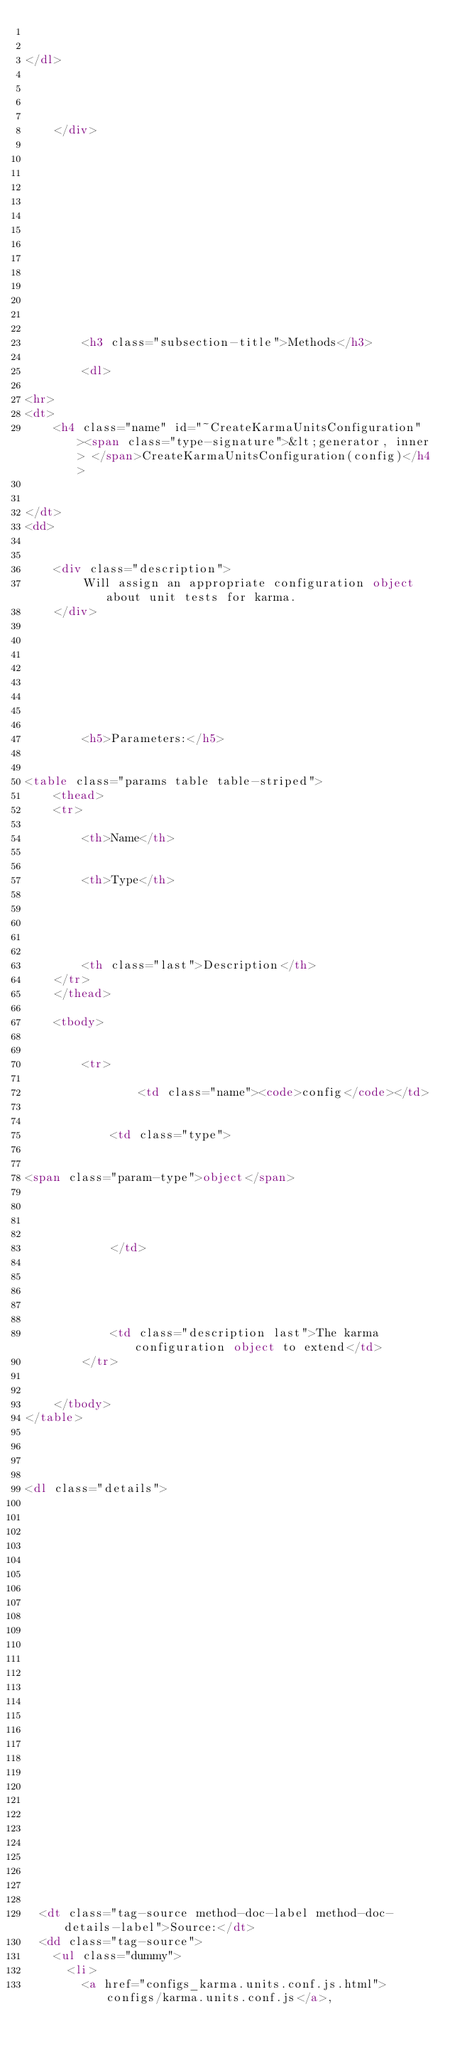<code> <loc_0><loc_0><loc_500><loc_500><_HTML_>
	
</dl>


        
    
    </div>

    

    

    

    

    

    

    
        <h3 class="subsection-title">Methods</h3>

        <dl>
            
<hr>
<dt>
    <h4 class="name" id="~CreateKarmaUnitsConfiguration"><span class="type-signature">&lt;generator, inner> </span>CreateKarmaUnitsConfiguration(config)</h4>
    
    
</dt>
<dd>

    
    <div class="description">
        Will assign an appropriate configuration object about unit tests for karma.
    </div>
    

    

    

    
    
        <h5>Parameters:</h5>
        

<table class="params table table-striped">
    <thead>
    <tr>
        
        <th>Name</th>
        

        <th>Type</th>

        

        

        <th class="last">Description</th>
    </tr>
    </thead>

    <tbody>
    

        <tr>
            
                <td class="name"><code>config</code></td>
            

            <td class="type">
            
                
<span class="param-type">object</span>



            
            </td>

            

            

            <td class="description last">The karma configuration object to extend</td>
        </tr>

    
    </tbody>
</table>

    

    
<dl class="details">
    

	

	

	

    

    

    

    

	

	

	

	

	



	
	<dt class="tag-source method-doc-label method-doc-details-label">Source:</dt>
	<dd class="tag-source">
		<ul class="dummy">
			<li>
				<a href="configs_karma.units.conf.js.html">configs/karma.units.conf.js</a>,</code> 